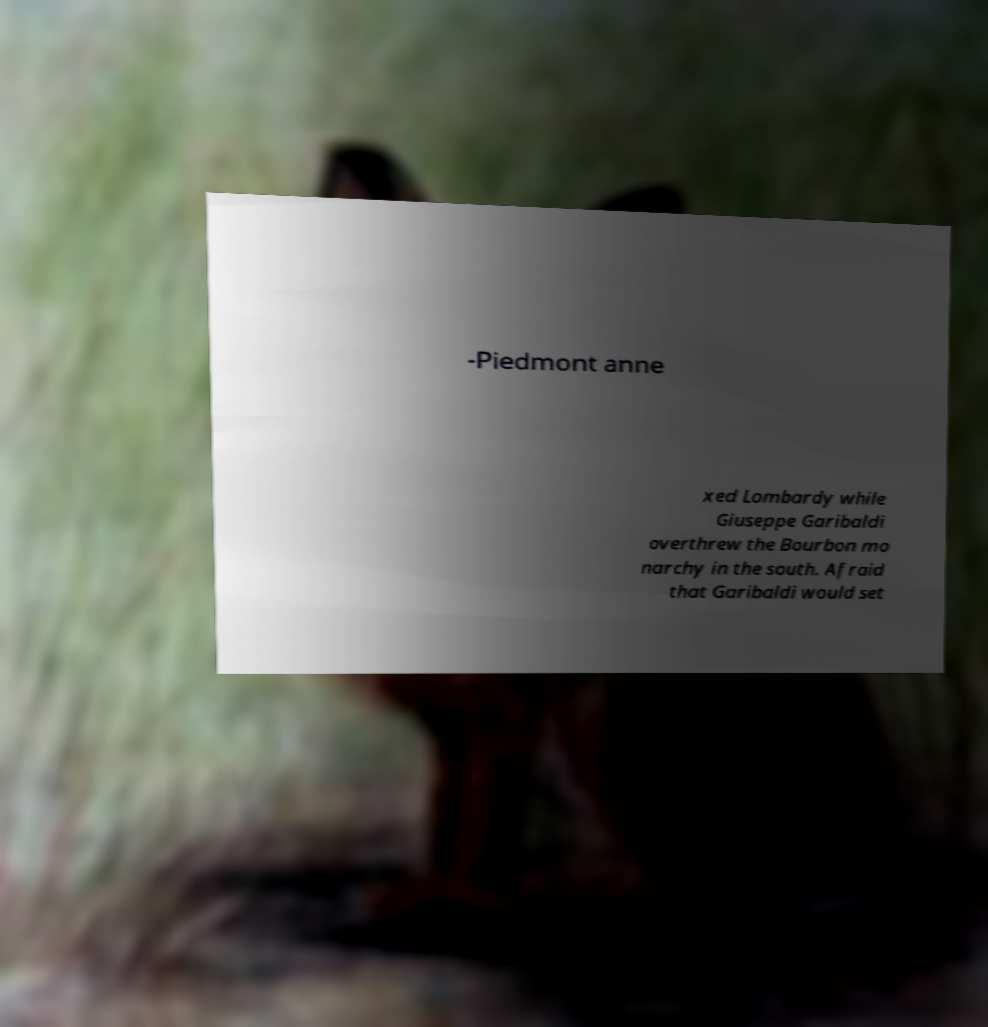Could you extract and type out the text from this image? -Piedmont anne xed Lombardy while Giuseppe Garibaldi overthrew the Bourbon mo narchy in the south. Afraid that Garibaldi would set 